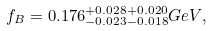Convert formula to latex. <formula><loc_0><loc_0><loc_500><loc_500>f _ { B } = 0 . 1 7 6 ^ { + 0 . 0 2 8 + 0 . 0 2 0 } _ { - 0 . 0 2 3 - 0 . 0 1 8 } { G e V } ,</formula> 